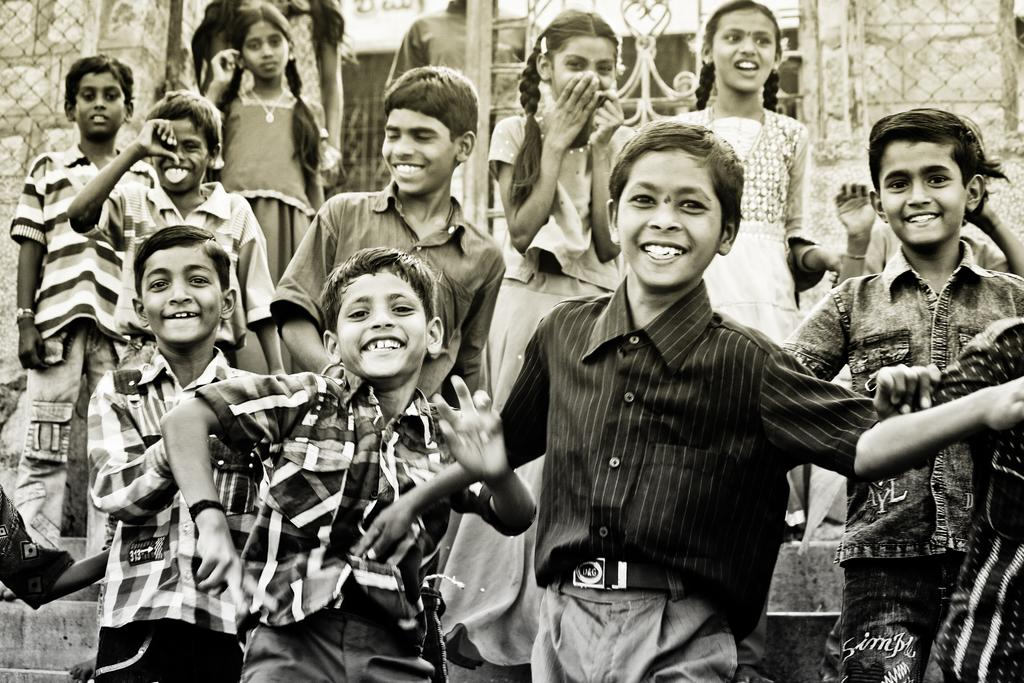What is the color scheme of the image? The image is black and white. Who is present in the image? There are children in the image. What is the emotional state of the children? The children are smiling. What can be seen in the background of the image? There is a wall, a mesh, and a board in the background of the image. Are there any other people visible in the image? Yes, there are people in the background of the image. What type of sky is visible in the image? There is no sky visible in the image, as it is a black and white photograph. How does the concept of death relate to the image? The image does not depict or reference any aspect of death, so it cannot be related to the concept. 